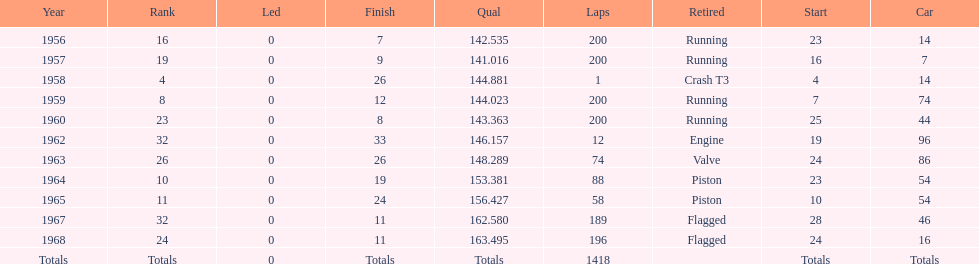What was its best starting position? 4. 